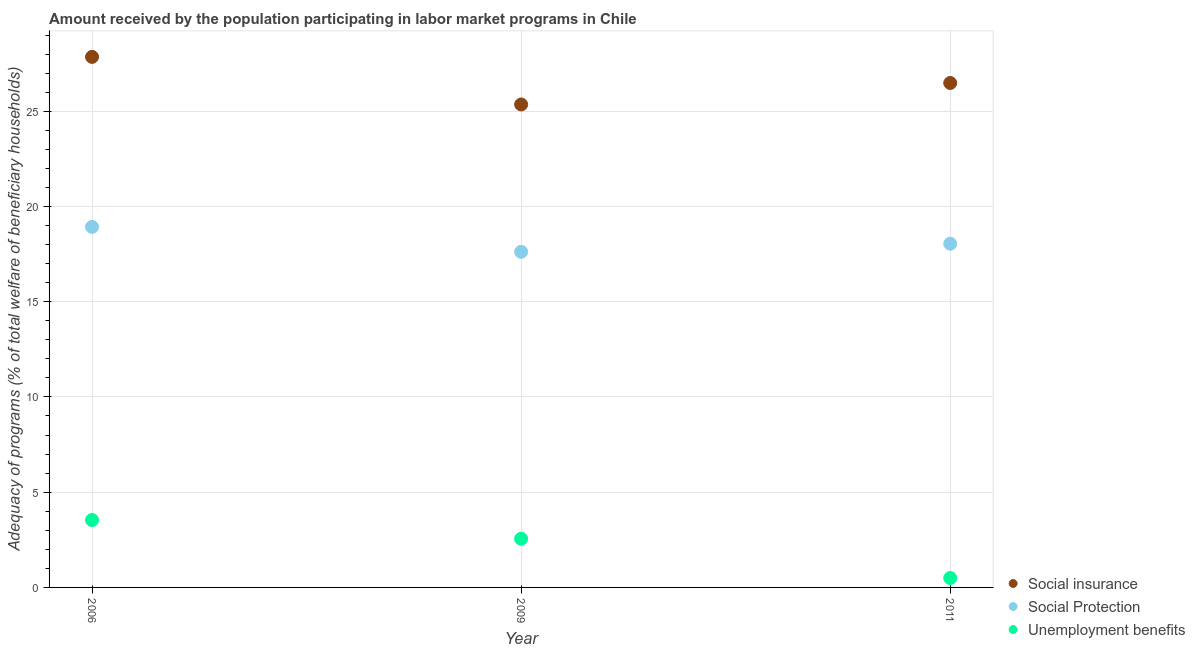Is the number of dotlines equal to the number of legend labels?
Keep it short and to the point. Yes. What is the amount received by the population participating in unemployment benefits programs in 2006?
Make the answer very short. 3.54. Across all years, what is the maximum amount received by the population participating in social protection programs?
Provide a short and direct response. 18.93. Across all years, what is the minimum amount received by the population participating in social insurance programs?
Offer a very short reply. 25.36. In which year was the amount received by the population participating in unemployment benefits programs maximum?
Ensure brevity in your answer.  2006. In which year was the amount received by the population participating in unemployment benefits programs minimum?
Provide a succinct answer. 2011. What is the total amount received by the population participating in social protection programs in the graph?
Offer a very short reply. 54.59. What is the difference between the amount received by the population participating in unemployment benefits programs in 2006 and that in 2011?
Ensure brevity in your answer.  3.04. What is the difference between the amount received by the population participating in social protection programs in 2011 and the amount received by the population participating in unemployment benefits programs in 2009?
Your answer should be very brief. 15.49. What is the average amount received by the population participating in unemployment benefits programs per year?
Give a very brief answer. 2.2. In the year 2011, what is the difference between the amount received by the population participating in social protection programs and amount received by the population participating in unemployment benefits programs?
Give a very brief answer. 17.55. In how many years, is the amount received by the population participating in social insurance programs greater than 22 %?
Provide a short and direct response. 3. What is the ratio of the amount received by the population participating in social insurance programs in 2009 to that in 2011?
Keep it short and to the point. 0.96. Is the amount received by the population participating in social insurance programs in 2009 less than that in 2011?
Keep it short and to the point. Yes. Is the difference between the amount received by the population participating in social protection programs in 2006 and 2009 greater than the difference between the amount received by the population participating in social insurance programs in 2006 and 2009?
Provide a succinct answer. No. What is the difference between the highest and the second highest amount received by the population participating in unemployment benefits programs?
Provide a succinct answer. 0.98. What is the difference between the highest and the lowest amount received by the population participating in unemployment benefits programs?
Ensure brevity in your answer.  3.04. Is the sum of the amount received by the population participating in unemployment benefits programs in 2006 and 2009 greater than the maximum amount received by the population participating in social protection programs across all years?
Provide a succinct answer. No. Is the amount received by the population participating in unemployment benefits programs strictly less than the amount received by the population participating in social protection programs over the years?
Provide a succinct answer. Yes. How many dotlines are there?
Provide a succinct answer. 3. What is the difference between two consecutive major ticks on the Y-axis?
Keep it short and to the point. 5. Does the graph contain any zero values?
Provide a short and direct response. No. Does the graph contain grids?
Provide a short and direct response. Yes. How are the legend labels stacked?
Provide a succinct answer. Vertical. What is the title of the graph?
Make the answer very short. Amount received by the population participating in labor market programs in Chile. What is the label or title of the Y-axis?
Your response must be concise. Adequacy of programs (% of total welfare of beneficiary households). What is the Adequacy of programs (% of total welfare of beneficiary households) in Social insurance in 2006?
Keep it short and to the point. 27.85. What is the Adequacy of programs (% of total welfare of beneficiary households) in Social Protection in 2006?
Offer a terse response. 18.93. What is the Adequacy of programs (% of total welfare of beneficiary households) of Unemployment benefits in 2006?
Make the answer very short. 3.54. What is the Adequacy of programs (% of total welfare of beneficiary households) of Social insurance in 2009?
Keep it short and to the point. 25.36. What is the Adequacy of programs (% of total welfare of beneficiary households) in Social Protection in 2009?
Provide a short and direct response. 17.62. What is the Adequacy of programs (% of total welfare of beneficiary households) of Unemployment benefits in 2009?
Your response must be concise. 2.55. What is the Adequacy of programs (% of total welfare of beneficiary households) in Social insurance in 2011?
Ensure brevity in your answer.  26.48. What is the Adequacy of programs (% of total welfare of beneficiary households) of Social Protection in 2011?
Keep it short and to the point. 18.05. What is the Adequacy of programs (% of total welfare of beneficiary households) of Unemployment benefits in 2011?
Offer a very short reply. 0.49. Across all years, what is the maximum Adequacy of programs (% of total welfare of beneficiary households) of Social insurance?
Make the answer very short. 27.85. Across all years, what is the maximum Adequacy of programs (% of total welfare of beneficiary households) of Social Protection?
Ensure brevity in your answer.  18.93. Across all years, what is the maximum Adequacy of programs (% of total welfare of beneficiary households) in Unemployment benefits?
Ensure brevity in your answer.  3.54. Across all years, what is the minimum Adequacy of programs (% of total welfare of beneficiary households) of Social insurance?
Your answer should be very brief. 25.36. Across all years, what is the minimum Adequacy of programs (% of total welfare of beneficiary households) in Social Protection?
Give a very brief answer. 17.62. Across all years, what is the minimum Adequacy of programs (% of total welfare of beneficiary households) of Unemployment benefits?
Keep it short and to the point. 0.49. What is the total Adequacy of programs (% of total welfare of beneficiary households) in Social insurance in the graph?
Keep it short and to the point. 79.69. What is the total Adequacy of programs (% of total welfare of beneficiary households) in Social Protection in the graph?
Provide a short and direct response. 54.59. What is the total Adequacy of programs (% of total welfare of beneficiary households) in Unemployment benefits in the graph?
Your response must be concise. 6.59. What is the difference between the Adequacy of programs (% of total welfare of beneficiary households) in Social insurance in 2006 and that in 2009?
Provide a short and direct response. 2.5. What is the difference between the Adequacy of programs (% of total welfare of beneficiary households) in Social Protection in 2006 and that in 2009?
Provide a short and direct response. 1.31. What is the difference between the Adequacy of programs (% of total welfare of beneficiary households) of Unemployment benefits in 2006 and that in 2009?
Offer a very short reply. 0.98. What is the difference between the Adequacy of programs (% of total welfare of beneficiary households) of Social insurance in 2006 and that in 2011?
Make the answer very short. 1.37. What is the difference between the Adequacy of programs (% of total welfare of beneficiary households) of Social Protection in 2006 and that in 2011?
Provide a short and direct response. 0.88. What is the difference between the Adequacy of programs (% of total welfare of beneficiary households) of Unemployment benefits in 2006 and that in 2011?
Your answer should be very brief. 3.04. What is the difference between the Adequacy of programs (% of total welfare of beneficiary households) in Social insurance in 2009 and that in 2011?
Your response must be concise. -1.13. What is the difference between the Adequacy of programs (% of total welfare of beneficiary households) of Social Protection in 2009 and that in 2011?
Provide a succinct answer. -0.42. What is the difference between the Adequacy of programs (% of total welfare of beneficiary households) of Unemployment benefits in 2009 and that in 2011?
Provide a short and direct response. 2.06. What is the difference between the Adequacy of programs (% of total welfare of beneficiary households) in Social insurance in 2006 and the Adequacy of programs (% of total welfare of beneficiary households) in Social Protection in 2009?
Keep it short and to the point. 10.23. What is the difference between the Adequacy of programs (% of total welfare of beneficiary households) of Social insurance in 2006 and the Adequacy of programs (% of total welfare of beneficiary households) of Unemployment benefits in 2009?
Make the answer very short. 25.3. What is the difference between the Adequacy of programs (% of total welfare of beneficiary households) in Social Protection in 2006 and the Adequacy of programs (% of total welfare of beneficiary households) in Unemployment benefits in 2009?
Make the answer very short. 16.37. What is the difference between the Adequacy of programs (% of total welfare of beneficiary households) of Social insurance in 2006 and the Adequacy of programs (% of total welfare of beneficiary households) of Social Protection in 2011?
Make the answer very short. 9.81. What is the difference between the Adequacy of programs (% of total welfare of beneficiary households) in Social insurance in 2006 and the Adequacy of programs (% of total welfare of beneficiary households) in Unemployment benefits in 2011?
Your answer should be very brief. 27.36. What is the difference between the Adequacy of programs (% of total welfare of beneficiary households) in Social Protection in 2006 and the Adequacy of programs (% of total welfare of beneficiary households) in Unemployment benefits in 2011?
Your answer should be compact. 18.43. What is the difference between the Adequacy of programs (% of total welfare of beneficiary households) in Social insurance in 2009 and the Adequacy of programs (% of total welfare of beneficiary households) in Social Protection in 2011?
Offer a very short reply. 7.31. What is the difference between the Adequacy of programs (% of total welfare of beneficiary households) in Social insurance in 2009 and the Adequacy of programs (% of total welfare of beneficiary households) in Unemployment benefits in 2011?
Offer a very short reply. 24.86. What is the difference between the Adequacy of programs (% of total welfare of beneficiary households) of Social Protection in 2009 and the Adequacy of programs (% of total welfare of beneficiary households) of Unemployment benefits in 2011?
Provide a succinct answer. 17.13. What is the average Adequacy of programs (% of total welfare of beneficiary households) in Social insurance per year?
Offer a very short reply. 26.56. What is the average Adequacy of programs (% of total welfare of beneficiary households) of Social Protection per year?
Provide a succinct answer. 18.2. What is the average Adequacy of programs (% of total welfare of beneficiary households) in Unemployment benefits per year?
Provide a succinct answer. 2.2. In the year 2006, what is the difference between the Adequacy of programs (% of total welfare of beneficiary households) in Social insurance and Adequacy of programs (% of total welfare of beneficiary households) in Social Protection?
Provide a short and direct response. 8.93. In the year 2006, what is the difference between the Adequacy of programs (% of total welfare of beneficiary households) in Social insurance and Adequacy of programs (% of total welfare of beneficiary households) in Unemployment benefits?
Give a very brief answer. 24.32. In the year 2006, what is the difference between the Adequacy of programs (% of total welfare of beneficiary households) in Social Protection and Adequacy of programs (% of total welfare of beneficiary households) in Unemployment benefits?
Give a very brief answer. 15.39. In the year 2009, what is the difference between the Adequacy of programs (% of total welfare of beneficiary households) of Social insurance and Adequacy of programs (% of total welfare of beneficiary households) of Social Protection?
Offer a very short reply. 7.73. In the year 2009, what is the difference between the Adequacy of programs (% of total welfare of beneficiary households) in Social insurance and Adequacy of programs (% of total welfare of beneficiary households) in Unemployment benefits?
Your answer should be compact. 22.8. In the year 2009, what is the difference between the Adequacy of programs (% of total welfare of beneficiary households) in Social Protection and Adequacy of programs (% of total welfare of beneficiary households) in Unemployment benefits?
Your answer should be very brief. 15.07. In the year 2011, what is the difference between the Adequacy of programs (% of total welfare of beneficiary households) in Social insurance and Adequacy of programs (% of total welfare of beneficiary households) in Social Protection?
Your answer should be compact. 8.44. In the year 2011, what is the difference between the Adequacy of programs (% of total welfare of beneficiary households) of Social insurance and Adequacy of programs (% of total welfare of beneficiary households) of Unemployment benefits?
Your answer should be very brief. 25.99. In the year 2011, what is the difference between the Adequacy of programs (% of total welfare of beneficiary households) in Social Protection and Adequacy of programs (% of total welfare of beneficiary households) in Unemployment benefits?
Your answer should be very brief. 17.55. What is the ratio of the Adequacy of programs (% of total welfare of beneficiary households) in Social insurance in 2006 to that in 2009?
Provide a short and direct response. 1.1. What is the ratio of the Adequacy of programs (% of total welfare of beneficiary households) in Social Protection in 2006 to that in 2009?
Provide a succinct answer. 1.07. What is the ratio of the Adequacy of programs (% of total welfare of beneficiary households) in Unemployment benefits in 2006 to that in 2009?
Your answer should be compact. 1.38. What is the ratio of the Adequacy of programs (% of total welfare of beneficiary households) of Social insurance in 2006 to that in 2011?
Ensure brevity in your answer.  1.05. What is the ratio of the Adequacy of programs (% of total welfare of beneficiary households) of Social Protection in 2006 to that in 2011?
Offer a terse response. 1.05. What is the ratio of the Adequacy of programs (% of total welfare of beneficiary households) in Unemployment benefits in 2006 to that in 2011?
Your answer should be compact. 7.16. What is the ratio of the Adequacy of programs (% of total welfare of beneficiary households) of Social insurance in 2009 to that in 2011?
Give a very brief answer. 0.96. What is the ratio of the Adequacy of programs (% of total welfare of beneficiary households) of Social Protection in 2009 to that in 2011?
Keep it short and to the point. 0.98. What is the ratio of the Adequacy of programs (% of total welfare of beneficiary households) of Unemployment benefits in 2009 to that in 2011?
Make the answer very short. 5.17. What is the difference between the highest and the second highest Adequacy of programs (% of total welfare of beneficiary households) in Social insurance?
Provide a succinct answer. 1.37. What is the difference between the highest and the second highest Adequacy of programs (% of total welfare of beneficiary households) of Social Protection?
Offer a very short reply. 0.88. What is the difference between the highest and the second highest Adequacy of programs (% of total welfare of beneficiary households) of Unemployment benefits?
Give a very brief answer. 0.98. What is the difference between the highest and the lowest Adequacy of programs (% of total welfare of beneficiary households) of Social insurance?
Offer a terse response. 2.5. What is the difference between the highest and the lowest Adequacy of programs (% of total welfare of beneficiary households) in Social Protection?
Your response must be concise. 1.31. What is the difference between the highest and the lowest Adequacy of programs (% of total welfare of beneficiary households) in Unemployment benefits?
Offer a very short reply. 3.04. 